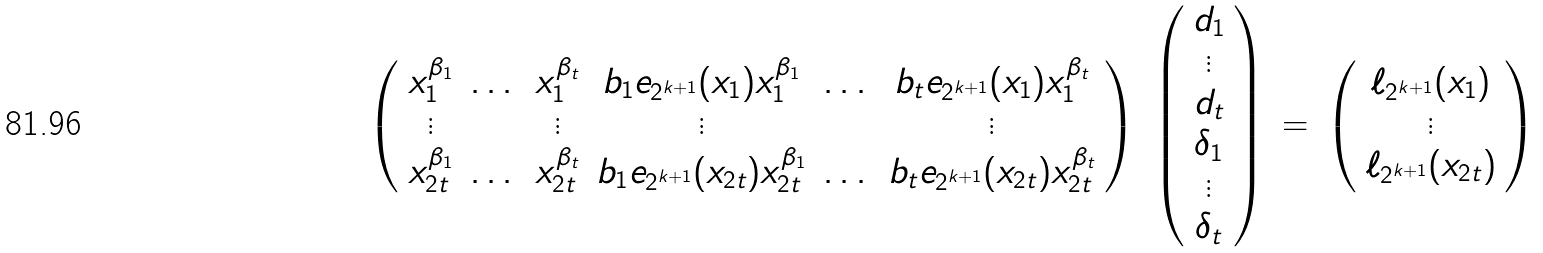Convert formula to latex. <formula><loc_0><loc_0><loc_500><loc_500>\begin{array} { c c c c } \left ( \begin{array} { c c c c c c } x _ { 1 } ^ { \beta _ { 1 } } & \dots & x _ { 1 } ^ { \beta _ { t } } & b _ { 1 } e _ { 2 ^ { k + 1 } } ( x _ { 1 } ) x _ { 1 } ^ { \beta _ { 1 } } & \dots & b _ { t } e _ { 2 ^ { k + 1 } } ( x _ { 1 } ) x _ { 1 } ^ { \beta _ { t } } \\ \vdots & & \vdots & \vdots & & \vdots \\ x _ { 2 t } ^ { \beta _ { 1 } } & \dots & x _ { 2 t } ^ { \beta _ { t } } & b _ { 1 } e _ { 2 ^ { k + 1 } } ( x _ { 2 t } ) x _ { 2 t } ^ { \beta _ { 1 } } & \dots & b _ { t } e _ { 2 ^ { k + 1 } } ( x _ { 2 t } ) x _ { 2 t } ^ { \beta _ { t } } \end{array} \right ) & \left ( \begin{array} { c } d _ { 1 } \\ \vdots \\ d _ { t } \\ \delta _ { 1 } \\ \vdots \\ \delta _ { t } \end{array} \right ) & = & \left ( \begin{array} { c } \ell _ { 2 ^ { k + 1 } } ( x _ { 1 } ) \\ \vdots \\ \ell _ { 2 ^ { k + 1 } } ( x _ { 2 t } ) \end{array} \right ) \end{array}</formula> 